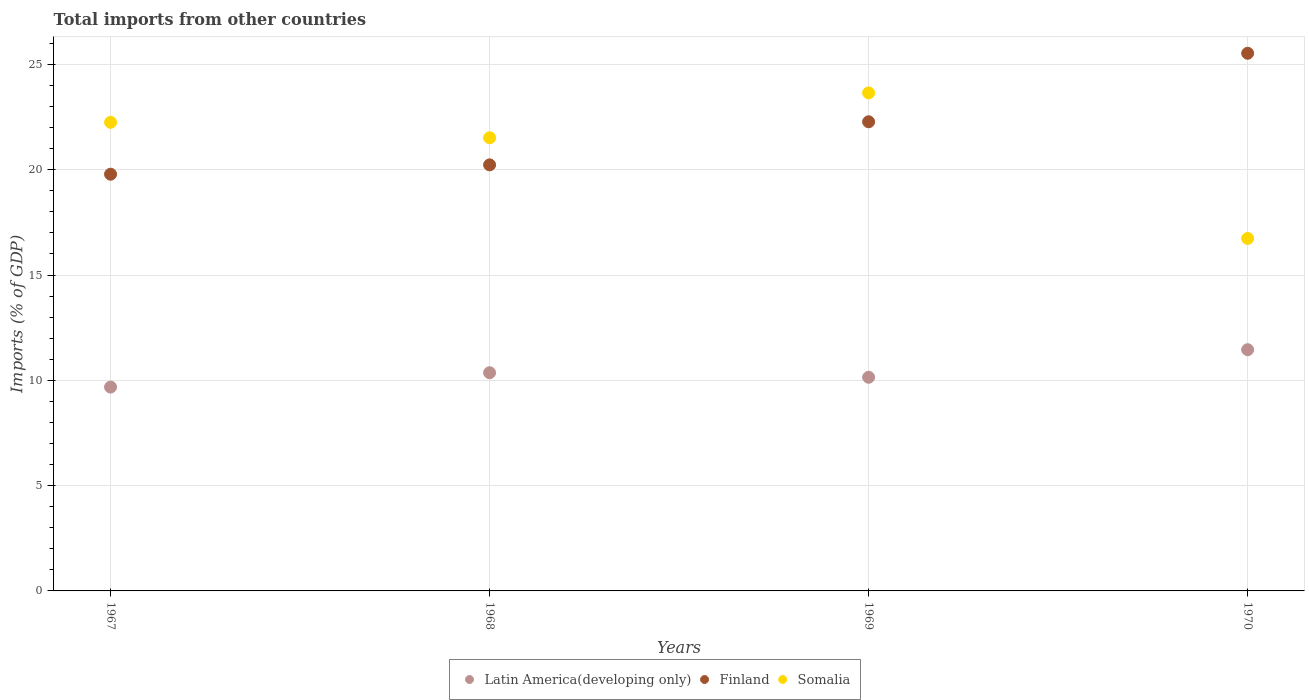What is the total imports in Latin America(developing only) in 1968?
Provide a succinct answer. 10.36. Across all years, what is the maximum total imports in Finland?
Ensure brevity in your answer.  25.53. Across all years, what is the minimum total imports in Latin America(developing only)?
Provide a short and direct response. 9.68. In which year was the total imports in Finland maximum?
Give a very brief answer. 1970. In which year was the total imports in Latin America(developing only) minimum?
Give a very brief answer. 1967. What is the total total imports in Finland in the graph?
Offer a terse response. 87.83. What is the difference between the total imports in Somalia in 1968 and that in 1969?
Provide a short and direct response. -2.13. What is the difference between the total imports in Finland in 1967 and the total imports in Somalia in 1968?
Offer a terse response. -1.73. What is the average total imports in Latin America(developing only) per year?
Your answer should be very brief. 10.41. In the year 1970, what is the difference between the total imports in Latin America(developing only) and total imports in Somalia?
Offer a very short reply. -5.28. In how many years, is the total imports in Latin America(developing only) greater than 12 %?
Keep it short and to the point. 0. What is the ratio of the total imports in Somalia in 1967 to that in 1969?
Your answer should be compact. 0.94. Is the difference between the total imports in Latin America(developing only) in 1967 and 1968 greater than the difference between the total imports in Somalia in 1967 and 1968?
Make the answer very short. No. What is the difference between the highest and the second highest total imports in Latin America(developing only)?
Make the answer very short. 1.09. What is the difference between the highest and the lowest total imports in Latin America(developing only)?
Make the answer very short. 1.77. In how many years, is the total imports in Finland greater than the average total imports in Finland taken over all years?
Your answer should be compact. 2. Is the sum of the total imports in Somalia in 1969 and 1970 greater than the maximum total imports in Latin America(developing only) across all years?
Offer a very short reply. Yes. Does the total imports in Latin America(developing only) monotonically increase over the years?
Your answer should be very brief. No. How many dotlines are there?
Ensure brevity in your answer.  3. How many years are there in the graph?
Keep it short and to the point. 4. Are the values on the major ticks of Y-axis written in scientific E-notation?
Your answer should be compact. No. Where does the legend appear in the graph?
Provide a short and direct response. Bottom center. What is the title of the graph?
Offer a very short reply. Total imports from other countries. What is the label or title of the Y-axis?
Your response must be concise. Imports (% of GDP). What is the Imports (% of GDP) of Latin America(developing only) in 1967?
Ensure brevity in your answer.  9.68. What is the Imports (% of GDP) of Finland in 1967?
Keep it short and to the point. 19.79. What is the Imports (% of GDP) in Somalia in 1967?
Ensure brevity in your answer.  22.25. What is the Imports (% of GDP) in Latin America(developing only) in 1968?
Give a very brief answer. 10.36. What is the Imports (% of GDP) of Finland in 1968?
Offer a terse response. 20.23. What is the Imports (% of GDP) in Somalia in 1968?
Your answer should be very brief. 21.52. What is the Imports (% of GDP) of Latin America(developing only) in 1969?
Offer a terse response. 10.15. What is the Imports (% of GDP) in Finland in 1969?
Provide a short and direct response. 22.28. What is the Imports (% of GDP) of Somalia in 1969?
Your answer should be very brief. 23.65. What is the Imports (% of GDP) of Latin America(developing only) in 1970?
Offer a very short reply. 11.45. What is the Imports (% of GDP) in Finland in 1970?
Your answer should be very brief. 25.53. What is the Imports (% of GDP) of Somalia in 1970?
Provide a short and direct response. 16.74. Across all years, what is the maximum Imports (% of GDP) of Latin America(developing only)?
Provide a succinct answer. 11.45. Across all years, what is the maximum Imports (% of GDP) of Finland?
Make the answer very short. 25.53. Across all years, what is the maximum Imports (% of GDP) in Somalia?
Provide a short and direct response. 23.65. Across all years, what is the minimum Imports (% of GDP) in Latin America(developing only)?
Give a very brief answer. 9.68. Across all years, what is the minimum Imports (% of GDP) of Finland?
Provide a succinct answer. 19.79. Across all years, what is the minimum Imports (% of GDP) of Somalia?
Offer a very short reply. 16.74. What is the total Imports (% of GDP) in Latin America(developing only) in the graph?
Give a very brief answer. 41.64. What is the total Imports (% of GDP) of Finland in the graph?
Offer a terse response. 87.83. What is the total Imports (% of GDP) in Somalia in the graph?
Offer a very short reply. 84.16. What is the difference between the Imports (% of GDP) in Latin America(developing only) in 1967 and that in 1968?
Your answer should be very brief. -0.68. What is the difference between the Imports (% of GDP) of Finland in 1967 and that in 1968?
Make the answer very short. -0.44. What is the difference between the Imports (% of GDP) of Somalia in 1967 and that in 1968?
Your answer should be compact. 0.73. What is the difference between the Imports (% of GDP) of Latin America(developing only) in 1967 and that in 1969?
Provide a short and direct response. -0.47. What is the difference between the Imports (% of GDP) in Finland in 1967 and that in 1969?
Offer a terse response. -2.49. What is the difference between the Imports (% of GDP) in Somalia in 1967 and that in 1969?
Your answer should be compact. -1.4. What is the difference between the Imports (% of GDP) in Latin America(developing only) in 1967 and that in 1970?
Ensure brevity in your answer.  -1.77. What is the difference between the Imports (% of GDP) of Finland in 1967 and that in 1970?
Provide a short and direct response. -5.74. What is the difference between the Imports (% of GDP) in Somalia in 1967 and that in 1970?
Keep it short and to the point. 5.51. What is the difference between the Imports (% of GDP) in Latin America(developing only) in 1968 and that in 1969?
Give a very brief answer. 0.22. What is the difference between the Imports (% of GDP) in Finland in 1968 and that in 1969?
Your answer should be very brief. -2.05. What is the difference between the Imports (% of GDP) in Somalia in 1968 and that in 1969?
Offer a terse response. -2.13. What is the difference between the Imports (% of GDP) of Latin America(developing only) in 1968 and that in 1970?
Offer a very short reply. -1.09. What is the difference between the Imports (% of GDP) of Finland in 1968 and that in 1970?
Your response must be concise. -5.3. What is the difference between the Imports (% of GDP) of Somalia in 1968 and that in 1970?
Offer a terse response. 4.78. What is the difference between the Imports (% of GDP) of Latin America(developing only) in 1969 and that in 1970?
Offer a very short reply. -1.31. What is the difference between the Imports (% of GDP) of Finland in 1969 and that in 1970?
Your answer should be very brief. -3.25. What is the difference between the Imports (% of GDP) in Somalia in 1969 and that in 1970?
Offer a very short reply. 6.91. What is the difference between the Imports (% of GDP) in Latin America(developing only) in 1967 and the Imports (% of GDP) in Finland in 1968?
Your answer should be compact. -10.55. What is the difference between the Imports (% of GDP) of Latin America(developing only) in 1967 and the Imports (% of GDP) of Somalia in 1968?
Keep it short and to the point. -11.84. What is the difference between the Imports (% of GDP) of Finland in 1967 and the Imports (% of GDP) of Somalia in 1968?
Offer a very short reply. -1.73. What is the difference between the Imports (% of GDP) in Latin America(developing only) in 1967 and the Imports (% of GDP) in Finland in 1969?
Provide a short and direct response. -12.6. What is the difference between the Imports (% of GDP) of Latin America(developing only) in 1967 and the Imports (% of GDP) of Somalia in 1969?
Your answer should be compact. -13.97. What is the difference between the Imports (% of GDP) in Finland in 1967 and the Imports (% of GDP) in Somalia in 1969?
Offer a terse response. -3.86. What is the difference between the Imports (% of GDP) in Latin America(developing only) in 1967 and the Imports (% of GDP) in Finland in 1970?
Offer a terse response. -15.85. What is the difference between the Imports (% of GDP) of Latin America(developing only) in 1967 and the Imports (% of GDP) of Somalia in 1970?
Your answer should be very brief. -7.06. What is the difference between the Imports (% of GDP) in Finland in 1967 and the Imports (% of GDP) in Somalia in 1970?
Keep it short and to the point. 3.05. What is the difference between the Imports (% of GDP) of Latin America(developing only) in 1968 and the Imports (% of GDP) of Finland in 1969?
Ensure brevity in your answer.  -11.92. What is the difference between the Imports (% of GDP) in Latin America(developing only) in 1968 and the Imports (% of GDP) in Somalia in 1969?
Make the answer very short. -13.29. What is the difference between the Imports (% of GDP) of Finland in 1968 and the Imports (% of GDP) of Somalia in 1969?
Give a very brief answer. -3.42. What is the difference between the Imports (% of GDP) of Latin America(developing only) in 1968 and the Imports (% of GDP) of Finland in 1970?
Provide a short and direct response. -15.17. What is the difference between the Imports (% of GDP) in Latin America(developing only) in 1968 and the Imports (% of GDP) in Somalia in 1970?
Your response must be concise. -6.38. What is the difference between the Imports (% of GDP) of Finland in 1968 and the Imports (% of GDP) of Somalia in 1970?
Give a very brief answer. 3.49. What is the difference between the Imports (% of GDP) of Latin America(developing only) in 1969 and the Imports (% of GDP) of Finland in 1970?
Make the answer very short. -15.39. What is the difference between the Imports (% of GDP) of Latin America(developing only) in 1969 and the Imports (% of GDP) of Somalia in 1970?
Give a very brief answer. -6.59. What is the difference between the Imports (% of GDP) in Finland in 1969 and the Imports (% of GDP) in Somalia in 1970?
Offer a very short reply. 5.54. What is the average Imports (% of GDP) in Latin America(developing only) per year?
Your answer should be very brief. 10.41. What is the average Imports (% of GDP) of Finland per year?
Give a very brief answer. 21.96. What is the average Imports (% of GDP) of Somalia per year?
Your answer should be compact. 21.04. In the year 1967, what is the difference between the Imports (% of GDP) of Latin America(developing only) and Imports (% of GDP) of Finland?
Keep it short and to the point. -10.11. In the year 1967, what is the difference between the Imports (% of GDP) of Latin America(developing only) and Imports (% of GDP) of Somalia?
Your response must be concise. -12.57. In the year 1967, what is the difference between the Imports (% of GDP) in Finland and Imports (% of GDP) in Somalia?
Keep it short and to the point. -2.46. In the year 1968, what is the difference between the Imports (% of GDP) in Latin America(developing only) and Imports (% of GDP) in Finland?
Make the answer very short. -9.87. In the year 1968, what is the difference between the Imports (% of GDP) of Latin America(developing only) and Imports (% of GDP) of Somalia?
Offer a terse response. -11.16. In the year 1968, what is the difference between the Imports (% of GDP) in Finland and Imports (% of GDP) in Somalia?
Keep it short and to the point. -1.29. In the year 1969, what is the difference between the Imports (% of GDP) in Latin America(developing only) and Imports (% of GDP) in Finland?
Offer a terse response. -12.13. In the year 1969, what is the difference between the Imports (% of GDP) in Latin America(developing only) and Imports (% of GDP) in Somalia?
Keep it short and to the point. -13.51. In the year 1969, what is the difference between the Imports (% of GDP) in Finland and Imports (% of GDP) in Somalia?
Your response must be concise. -1.37. In the year 1970, what is the difference between the Imports (% of GDP) in Latin America(developing only) and Imports (% of GDP) in Finland?
Make the answer very short. -14.08. In the year 1970, what is the difference between the Imports (% of GDP) of Latin America(developing only) and Imports (% of GDP) of Somalia?
Provide a succinct answer. -5.28. In the year 1970, what is the difference between the Imports (% of GDP) of Finland and Imports (% of GDP) of Somalia?
Offer a terse response. 8.79. What is the ratio of the Imports (% of GDP) of Latin America(developing only) in 1967 to that in 1968?
Offer a very short reply. 0.93. What is the ratio of the Imports (% of GDP) of Finland in 1967 to that in 1968?
Ensure brevity in your answer.  0.98. What is the ratio of the Imports (% of GDP) in Somalia in 1967 to that in 1968?
Keep it short and to the point. 1.03. What is the ratio of the Imports (% of GDP) in Latin America(developing only) in 1967 to that in 1969?
Provide a short and direct response. 0.95. What is the ratio of the Imports (% of GDP) in Finland in 1967 to that in 1969?
Your response must be concise. 0.89. What is the ratio of the Imports (% of GDP) in Somalia in 1967 to that in 1969?
Ensure brevity in your answer.  0.94. What is the ratio of the Imports (% of GDP) in Latin America(developing only) in 1967 to that in 1970?
Your answer should be very brief. 0.85. What is the ratio of the Imports (% of GDP) in Finland in 1967 to that in 1970?
Ensure brevity in your answer.  0.78. What is the ratio of the Imports (% of GDP) in Somalia in 1967 to that in 1970?
Your answer should be very brief. 1.33. What is the ratio of the Imports (% of GDP) of Latin America(developing only) in 1968 to that in 1969?
Ensure brevity in your answer.  1.02. What is the ratio of the Imports (% of GDP) in Finland in 1968 to that in 1969?
Provide a succinct answer. 0.91. What is the ratio of the Imports (% of GDP) in Somalia in 1968 to that in 1969?
Your answer should be compact. 0.91. What is the ratio of the Imports (% of GDP) in Latin America(developing only) in 1968 to that in 1970?
Provide a short and direct response. 0.9. What is the ratio of the Imports (% of GDP) in Finland in 1968 to that in 1970?
Offer a terse response. 0.79. What is the ratio of the Imports (% of GDP) in Somalia in 1968 to that in 1970?
Give a very brief answer. 1.29. What is the ratio of the Imports (% of GDP) of Latin America(developing only) in 1969 to that in 1970?
Your answer should be compact. 0.89. What is the ratio of the Imports (% of GDP) of Finland in 1969 to that in 1970?
Provide a short and direct response. 0.87. What is the ratio of the Imports (% of GDP) of Somalia in 1969 to that in 1970?
Keep it short and to the point. 1.41. What is the difference between the highest and the second highest Imports (% of GDP) of Latin America(developing only)?
Provide a succinct answer. 1.09. What is the difference between the highest and the second highest Imports (% of GDP) of Finland?
Keep it short and to the point. 3.25. What is the difference between the highest and the second highest Imports (% of GDP) in Somalia?
Offer a very short reply. 1.4. What is the difference between the highest and the lowest Imports (% of GDP) of Latin America(developing only)?
Your answer should be compact. 1.77. What is the difference between the highest and the lowest Imports (% of GDP) of Finland?
Provide a succinct answer. 5.74. What is the difference between the highest and the lowest Imports (% of GDP) of Somalia?
Provide a succinct answer. 6.91. 